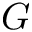<formula> <loc_0><loc_0><loc_500><loc_500>G</formula> 